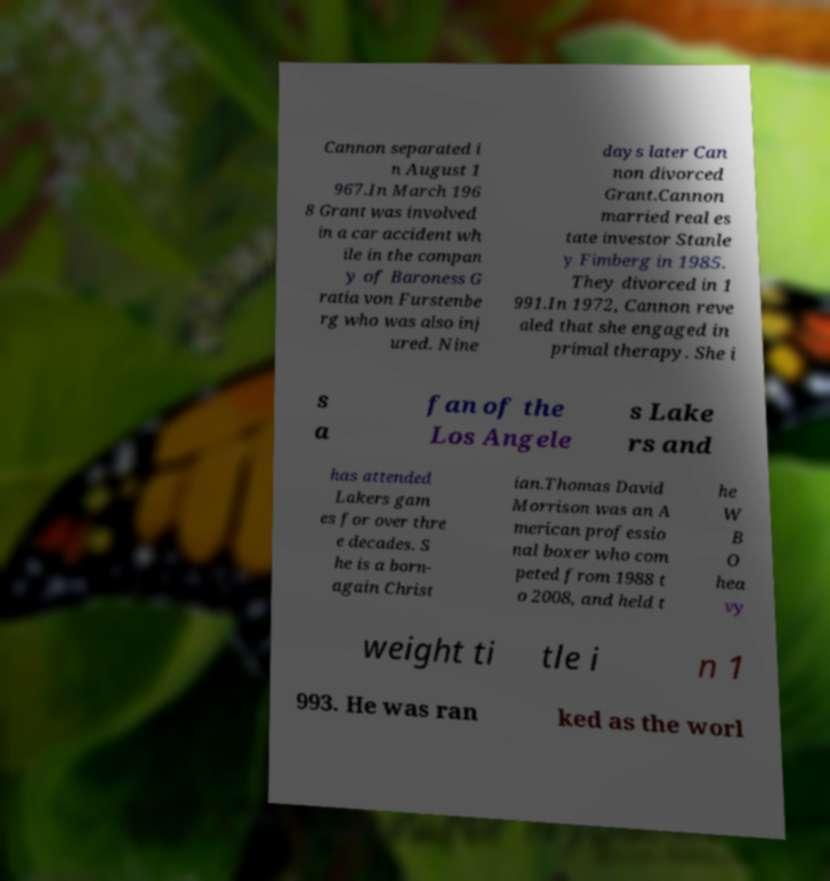Please read and relay the text visible in this image. What does it say? Cannon separated i n August 1 967.In March 196 8 Grant was involved in a car accident wh ile in the compan y of Baroness G ratia von Furstenbe rg who was also inj ured. Nine days later Can non divorced Grant.Cannon married real es tate investor Stanle y Fimberg in 1985. They divorced in 1 991.In 1972, Cannon reve aled that she engaged in primal therapy. She i s a fan of the Los Angele s Lake rs and has attended Lakers gam es for over thre e decades. S he is a born- again Christ ian.Thomas David Morrison was an A merican professio nal boxer who com peted from 1988 t o 2008, and held t he W B O hea vy weight ti tle i n 1 993. He was ran ked as the worl 